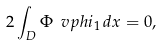Convert formula to latex. <formula><loc_0><loc_0><loc_500><loc_500>2 \int _ { D } \Phi \ v p h i _ { 1 } \, d x = 0 ,</formula> 